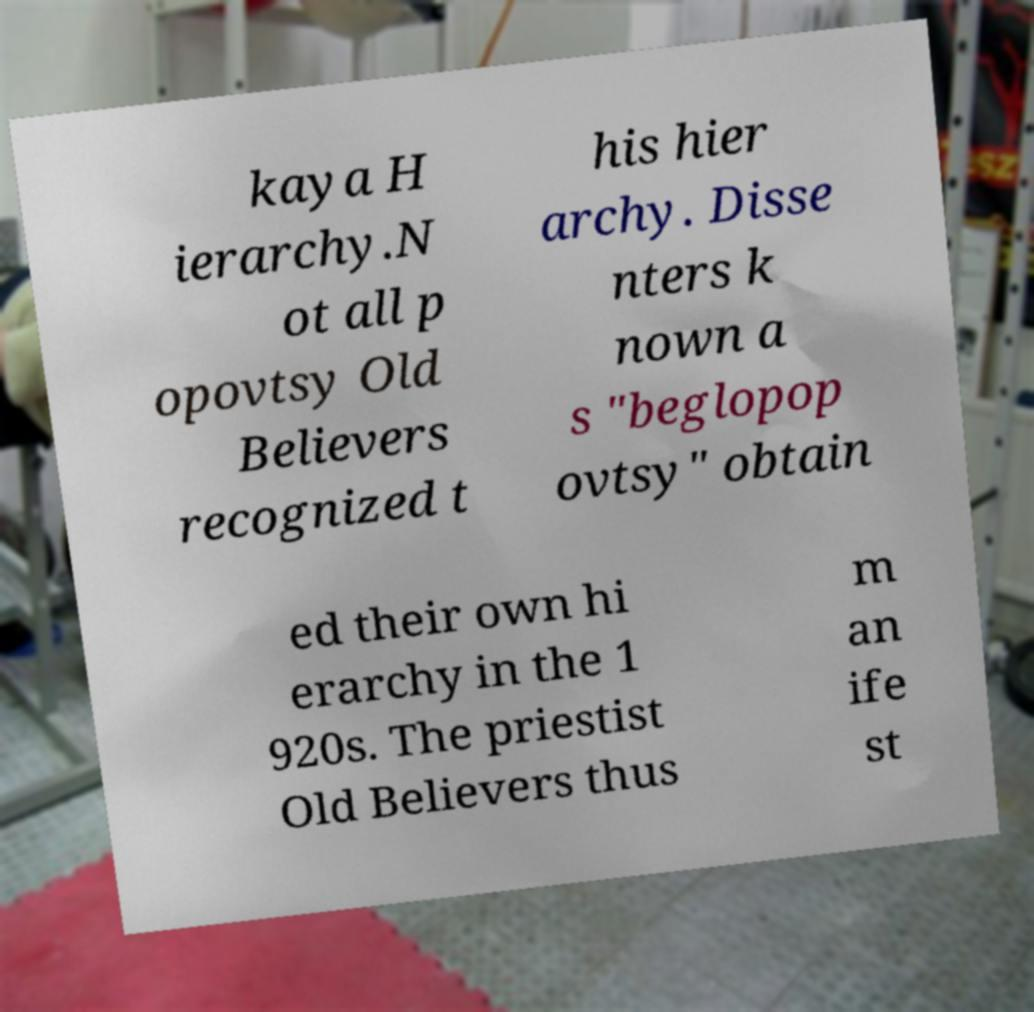There's text embedded in this image that I need extracted. Can you transcribe it verbatim? kaya H ierarchy.N ot all p opovtsy Old Believers recognized t his hier archy. Disse nters k nown a s "beglopop ovtsy" obtain ed their own hi erarchy in the 1 920s. The priestist Old Believers thus m an ife st 